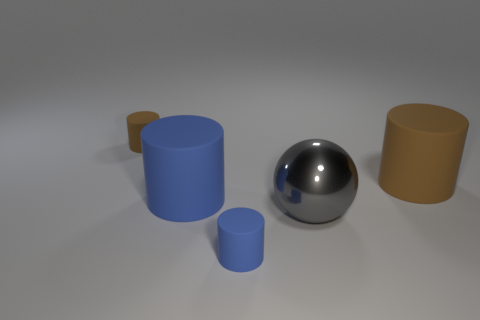Are there fewer big matte cylinders that are in front of the large blue rubber cylinder than big blue rubber objects that are to the left of the large brown rubber thing?
Provide a succinct answer. Yes. Is the size of the ball the same as the blue object in front of the metallic thing?
Ensure brevity in your answer.  No. The object that is both to the right of the small blue rubber cylinder and behind the gray metallic ball has what shape?
Your answer should be compact. Cylinder. There is a blue cylinder that is the same material as the tiny blue object; what size is it?
Keep it short and to the point. Large. What number of blue objects are in front of the blue matte object that is left of the small blue cylinder?
Your answer should be very brief. 1. Do the small thing in front of the small brown thing and the large gray thing have the same material?
Your answer should be very brief. No. Is there any other thing that has the same material as the big gray object?
Your answer should be compact. No. What is the size of the brown matte cylinder that is right of the small thing that is behind the shiny sphere?
Provide a short and direct response. Large. What is the size of the brown cylinder that is on the right side of the brown object that is on the left side of the brown rubber thing in front of the small brown object?
Make the answer very short. Large. There is a brown matte object that is right of the large blue rubber thing; is it the same shape as the brown rubber object left of the large gray thing?
Ensure brevity in your answer.  Yes. 